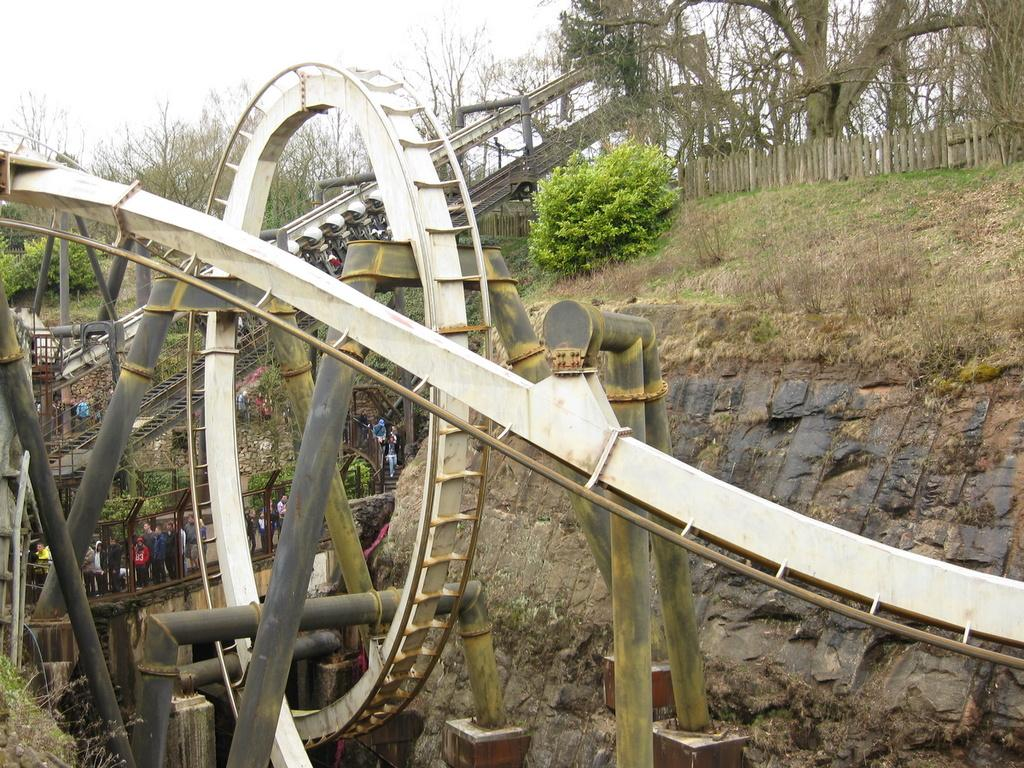What is the main subject of the image? The main subject of the image is a roller coaster. What are the people in the image doing? There are persons standing on a bridge in the image. What type of landscape can be seen in the image? Hills, bushes, trees, and a fence are visible in the image. What is visible in the background of the image? The sky is visible in the image. How are the persons in the image sorting the wires? There are no wires present in the image, and therefore no sorting activity can be observed. What scientific experiment is being conducted in the image? There is no scientific experiment depicted in the image; it features a roller coaster and people standing on a bridge. 